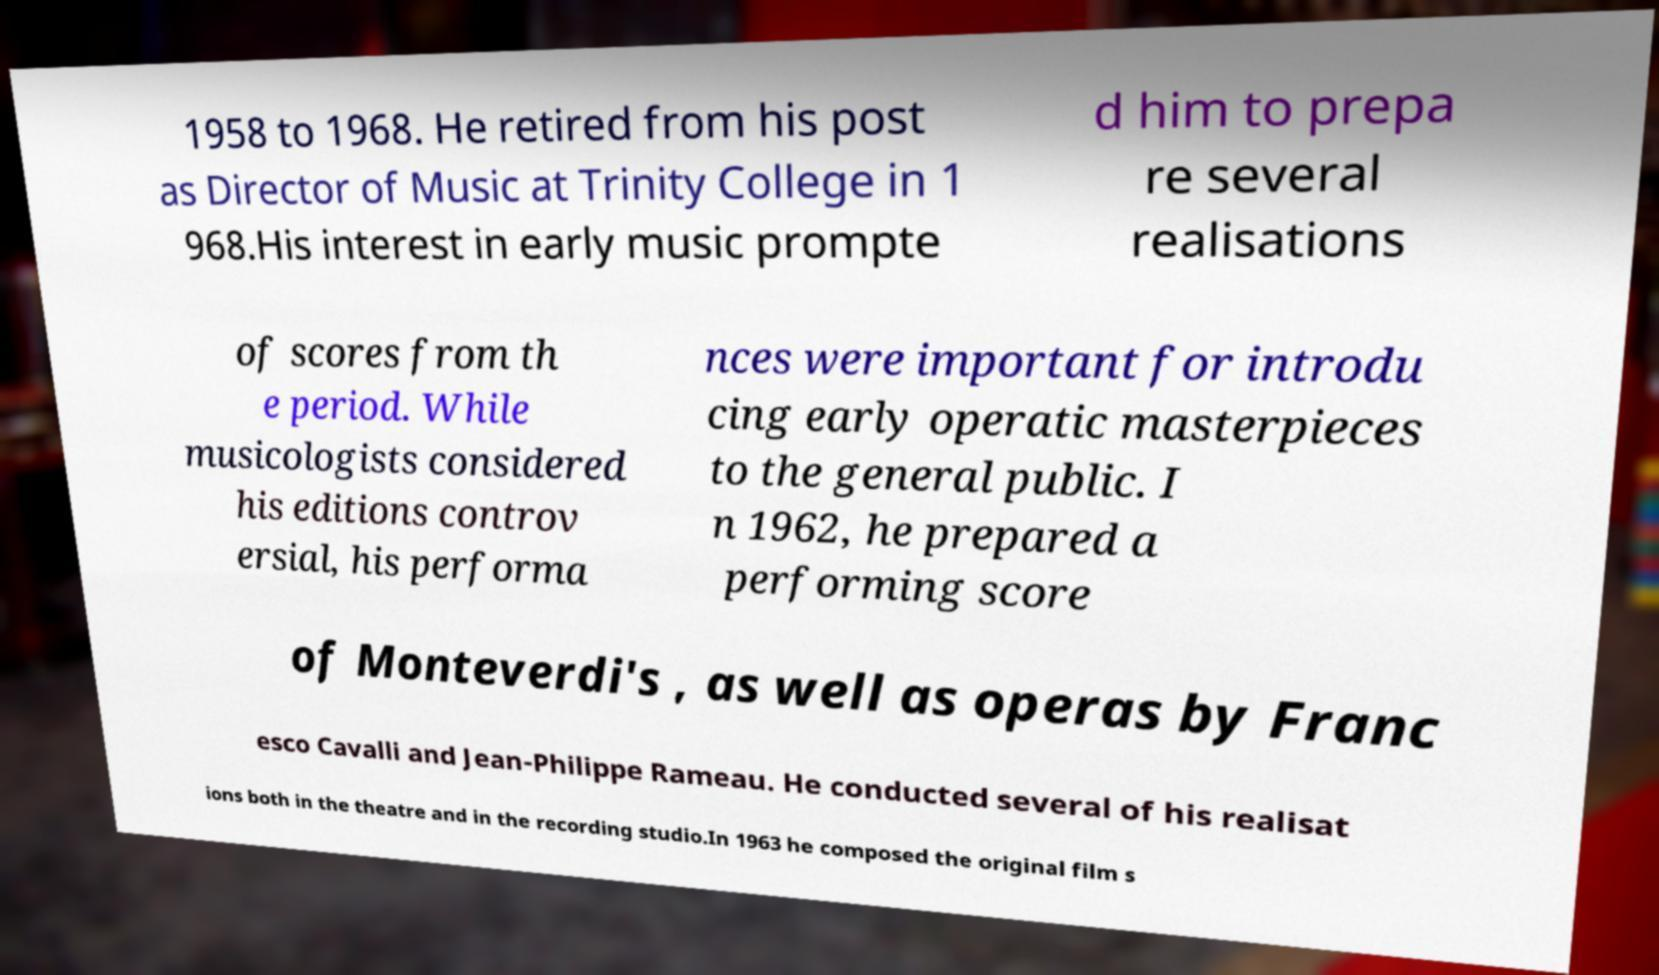There's text embedded in this image that I need extracted. Can you transcribe it verbatim? 1958 to 1968. He retired from his post as Director of Music at Trinity College in 1 968.His interest in early music prompte d him to prepa re several realisations of scores from th e period. While musicologists considered his editions controv ersial, his performa nces were important for introdu cing early operatic masterpieces to the general public. I n 1962, he prepared a performing score of Monteverdi's , as well as operas by Franc esco Cavalli and Jean-Philippe Rameau. He conducted several of his realisat ions both in the theatre and in the recording studio.In 1963 he composed the original film s 